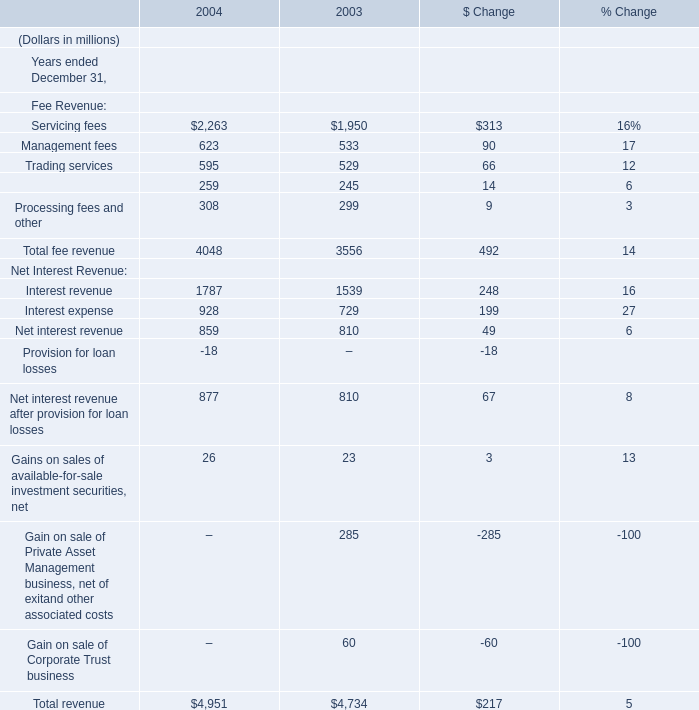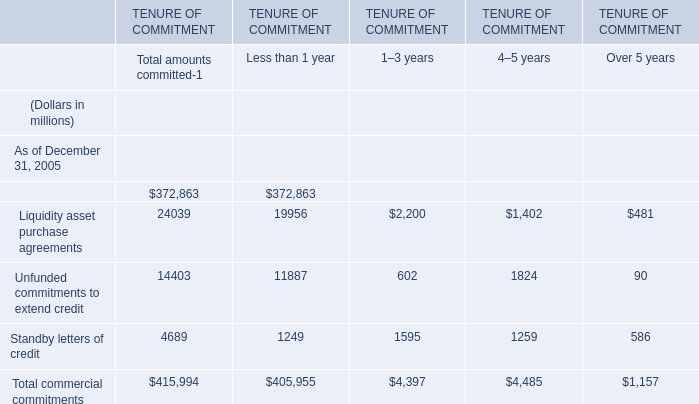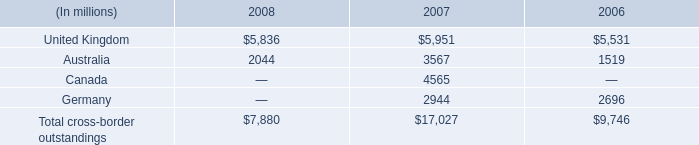in 2007 , what percent of cross border outstandings were in the united kingdom 
Computations: (5951 / 17027)
Answer: 0.3495. 